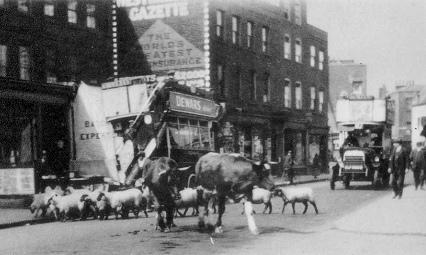What is in front of the vehicle? Please explain your reasoning. animals. The animals are in front. 